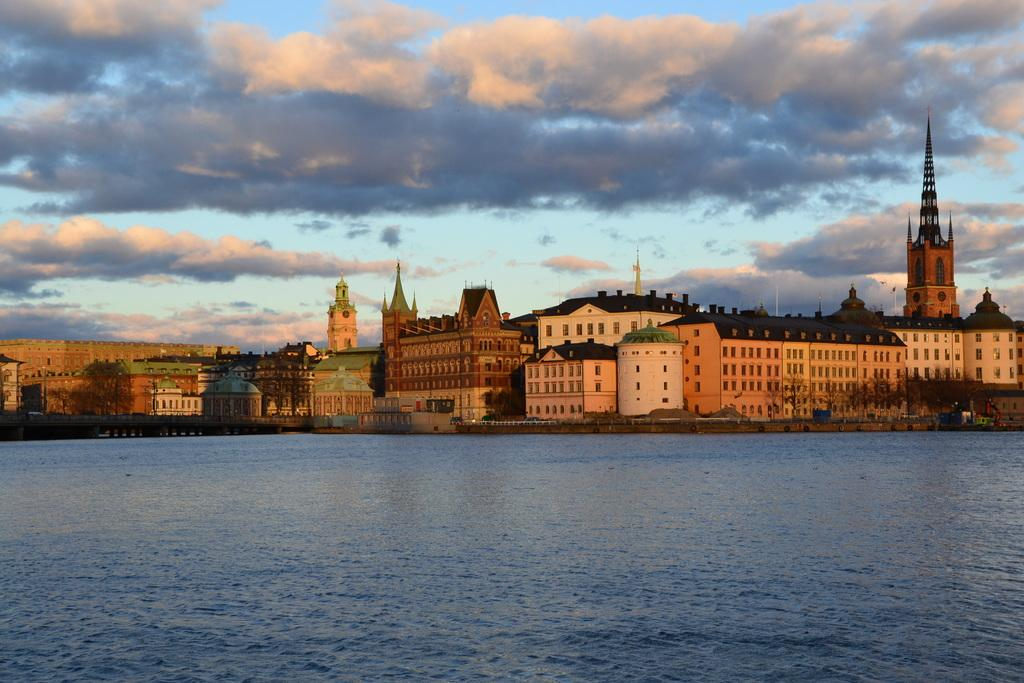What is the main element present in the image? There is water in the image. What can be seen in the distance behind the water? There are buildings in the background of the image. What feature do the buildings have? The buildings have windows. How would you describe the color of the sky in the image? The sky is blue in the image. Are there any additional features in the sky? Yes, there are clouds in the sky. How many cows are grazing in the water in the image? There are no cows present in the image; it features water, buildings, and a blue sky with clouds. 